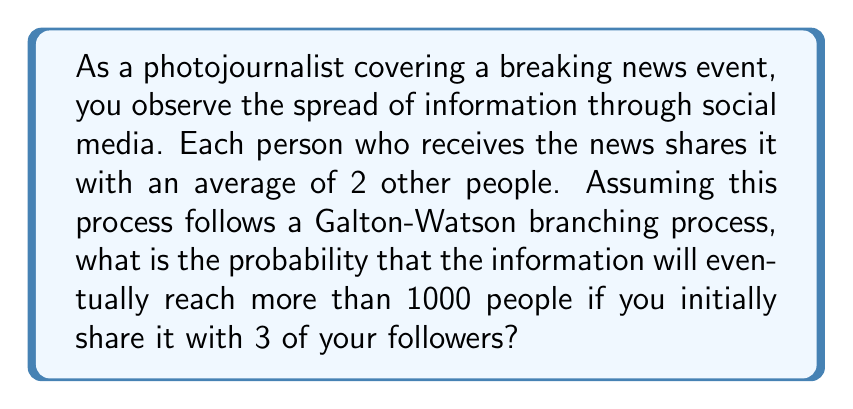What is the answer to this math problem? Let's approach this step-by-step using the theory of branching processes:

1) In a Galton-Watson branching process, we define the extinction probability $q$ as the probability that the process will eventually die out.

2) For our case, each person shares with an average of 2 others. This means the expected number of "offspring" $\mu = 2$.

3) The extinction probability $q$ satisfies the equation:

   $q = G(q)$

   where $G(s)$ is the probability generating function of the offspring distribution.

4) For a Poisson distribution with mean $\mu$, which is a good approximation for many real-world sharing behaviors, we have:

   $G(s) = e^{\mu(s-1)}$

5) Substituting $\mu = 2$, our equation becomes:

   $q = e^{2(q-1)}$

6) This equation can be solved numerically, giving $q \approx 0.2032$

7) The probability of non-extinction (i.e., the process continuing indefinitely) from a single initial share is therefore $1-q \approx 0.7968$

8) With 3 initial shares, the probability of at least one of these leading to non-extinction is:

   $1 - q^3 \approx 1 - 0.2032^3 \approx 0.9916$

9) If the process doesn't go extinct, it will eventually exceed any finite number (including 1000) with probability 1.

Therefore, the probability of reaching more than 1000 people is the same as the probability of non-extinction from 3 initial shares, which is approximately 0.9916 or 99.16%.
Answer: 0.9916 